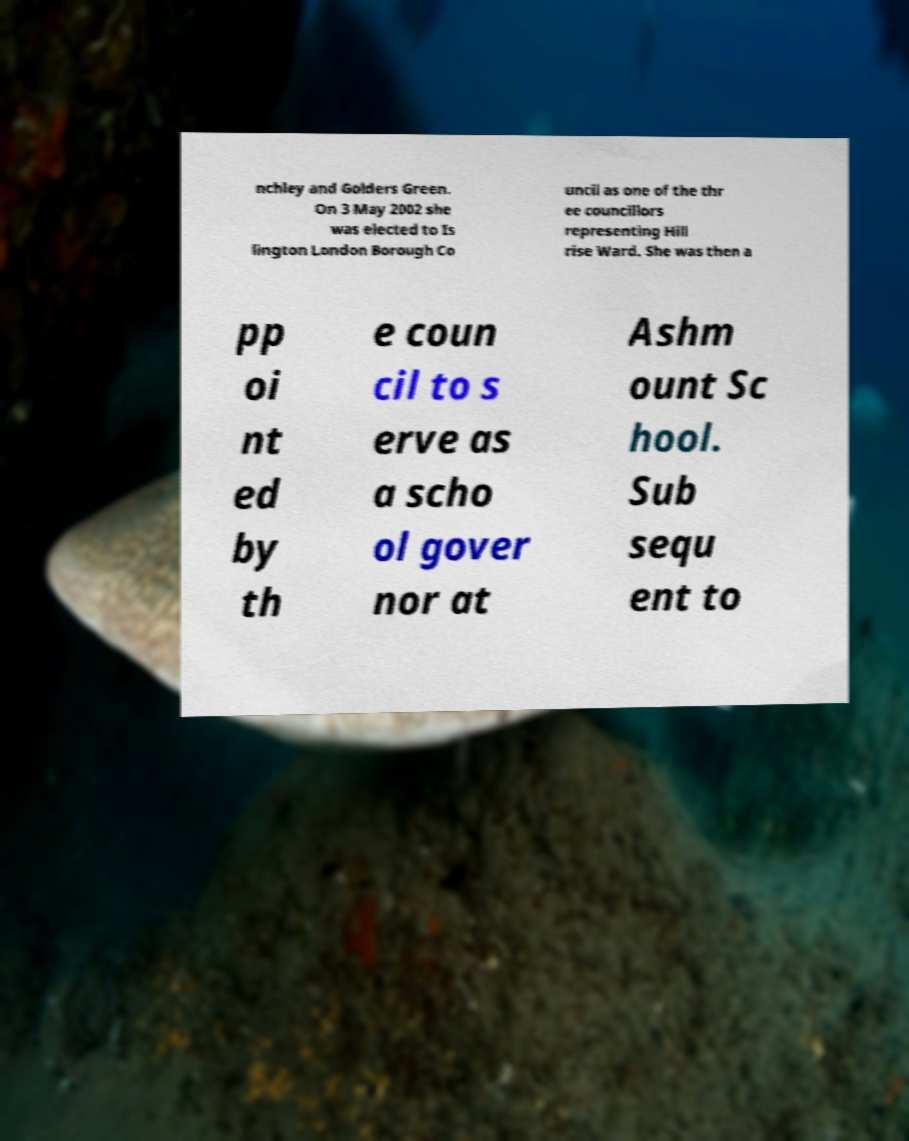There's text embedded in this image that I need extracted. Can you transcribe it verbatim? nchley and Golders Green. On 3 May 2002 she was elected to Is lington London Borough Co uncil as one of the thr ee councillors representing Hill rise Ward. She was then a pp oi nt ed by th e coun cil to s erve as a scho ol gover nor at Ashm ount Sc hool. Sub sequ ent to 